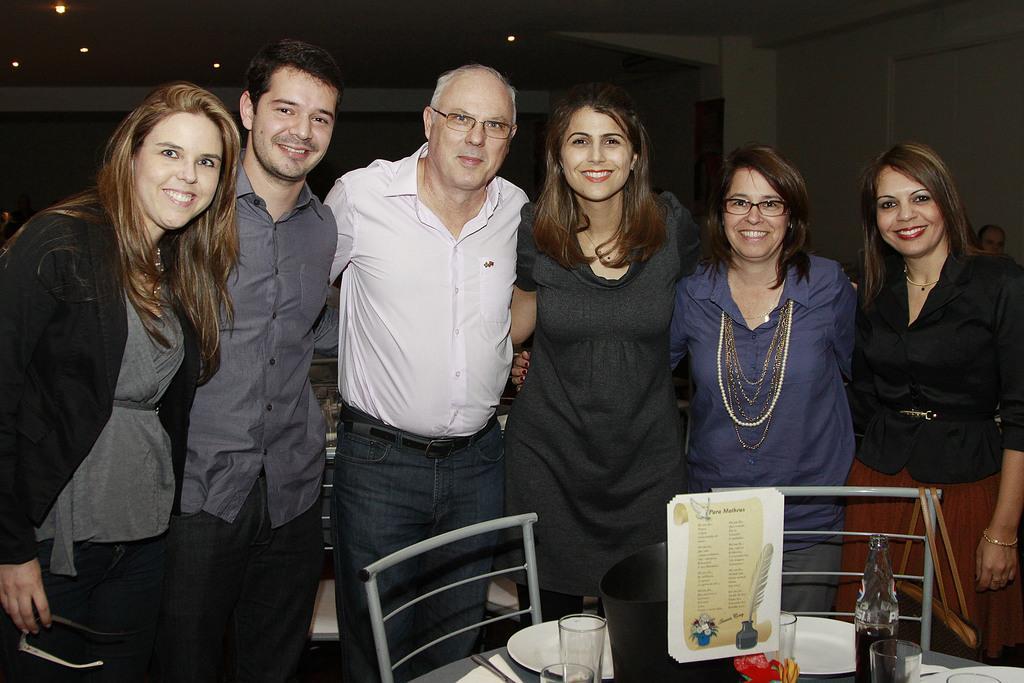How would you summarize this image in a sentence or two? In this image there are three women standing at the right side of the image. A woman standing at the left side is smiling. There are two persons at the middle where one is wearing white shirt and jeans and other is wearing a grey colour shirt and pant. there are two chairs before them. Before there is a table having plates, glass and bottle. 